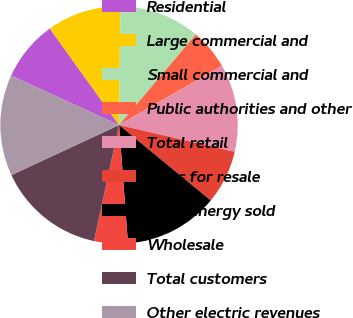Convert chart to OTSL. <chart><loc_0><loc_0><loc_500><loc_500><pie_chart><fcel>Residential<fcel>Large commercial and<fcel>Small commercial and<fcel>Public authorities and other<fcel>Total retail<fcel>Sales for resale<fcel>Total energy sold<fcel>Wholesale<fcel>Total customers<fcel>Other electric revenues<nl><fcel>8.26%<fcel>10.09%<fcel>11.01%<fcel>5.5%<fcel>11.93%<fcel>7.34%<fcel>12.84%<fcel>4.59%<fcel>14.68%<fcel>13.76%<nl></chart> 